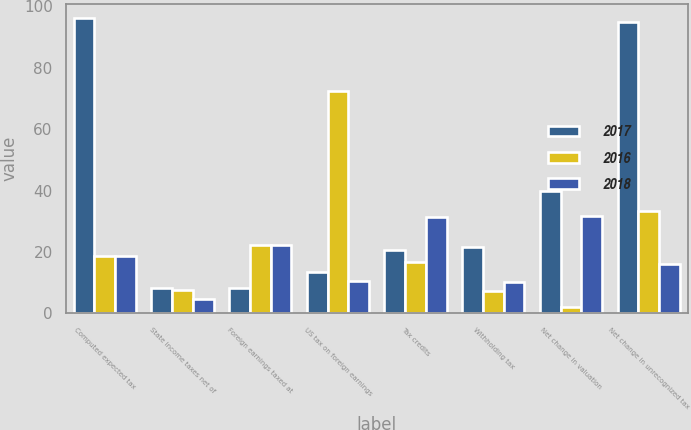<chart> <loc_0><loc_0><loc_500><loc_500><stacked_bar_chart><ecel><fcel>Computed expected tax<fcel>State income taxes net of<fcel>Foreign earnings taxed at<fcel>US tax on foreign earnings<fcel>Tax credits<fcel>Withholding tax<fcel>Net change in valuation<fcel>Net change in unrecognized tax<nl><fcel>2017<fcel>96.1<fcel>8.4<fcel>8.3<fcel>13.5<fcel>20.7<fcel>21.7<fcel>39.8<fcel>95<nl><fcel>2016<fcel>18.75<fcel>7.6<fcel>22.3<fcel>72.3<fcel>16.8<fcel>7.4<fcel>2<fcel>33.4<nl><fcel>2018<fcel>18.75<fcel>4.8<fcel>22.4<fcel>10.7<fcel>31.5<fcel>10.1<fcel>31.7<fcel>16<nl></chart> 